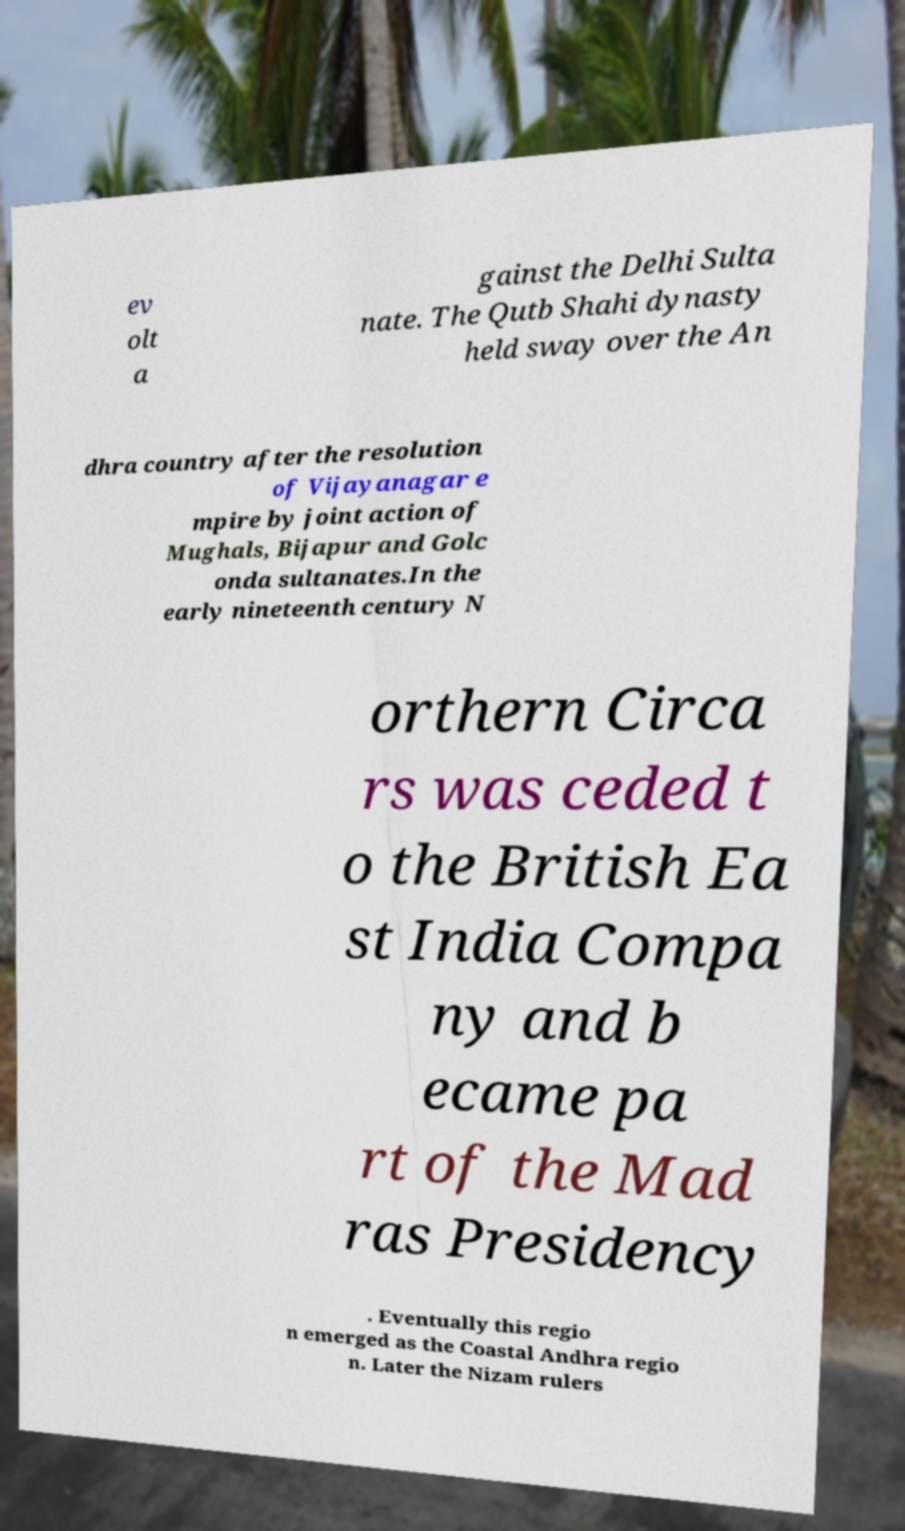Can you accurately transcribe the text from the provided image for me? ev olt a gainst the Delhi Sulta nate. The Qutb Shahi dynasty held sway over the An dhra country after the resolution of Vijayanagar e mpire by joint action of Mughals, Bijapur and Golc onda sultanates.In the early nineteenth century N orthern Circa rs was ceded t o the British Ea st India Compa ny and b ecame pa rt of the Mad ras Presidency . Eventually this regio n emerged as the Coastal Andhra regio n. Later the Nizam rulers 